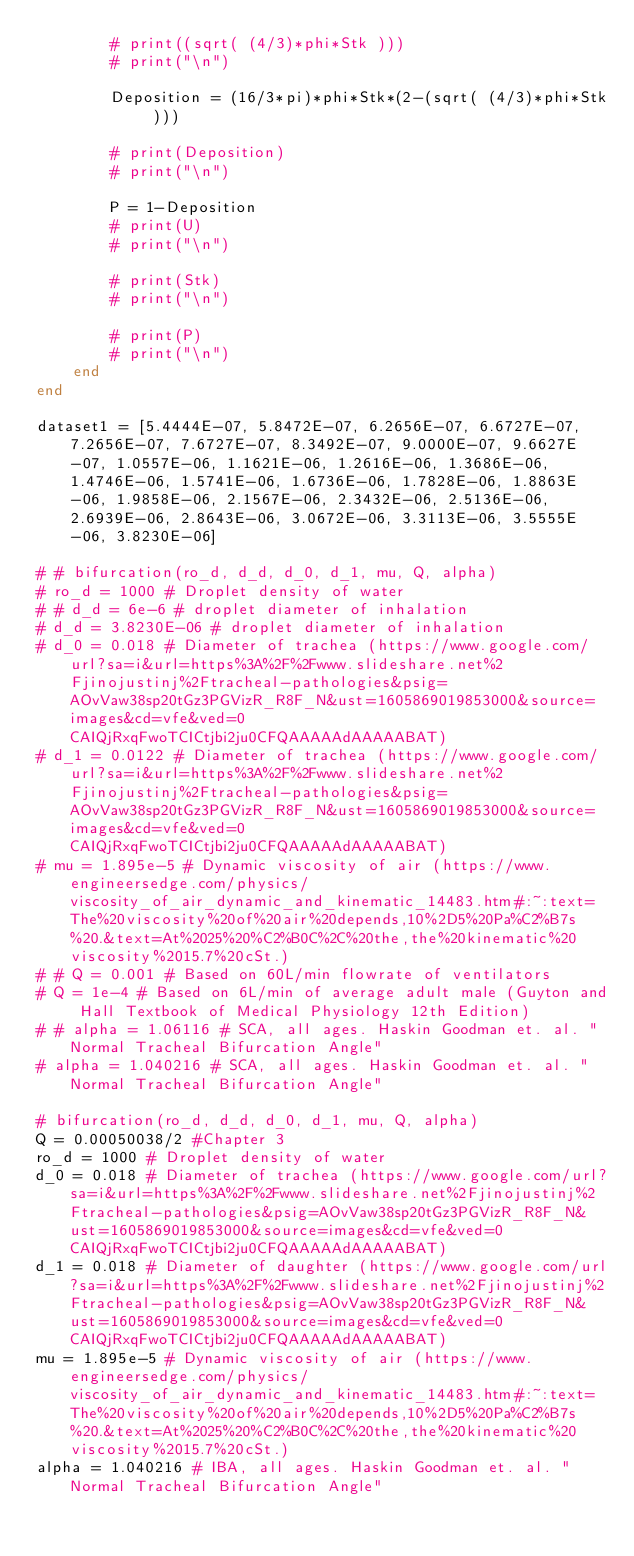<code> <loc_0><loc_0><loc_500><loc_500><_Julia_>        # print((sqrt( (4/3)*phi*Stk )))
        # print("\n")

        Deposition = (16/3*pi)*phi*Stk*(2-(sqrt( (4/3)*phi*Stk )))

        # print(Deposition)
        # print("\n")

        P = 1-Deposition
        # print(U)
        # print("\n")

        # print(Stk)
        # print("\n")

        # print(P)
        # print("\n")
    end
end

dataset1 = [5.4444E-07, 5.8472E-07, 6.2656E-07, 6.6727E-07, 7.2656E-07, 7.6727E-07, 8.3492E-07, 9.0000E-07, 9.6627E-07, 1.0557E-06, 1.1621E-06, 1.2616E-06, 1.3686E-06, 1.4746E-06, 1.5741E-06, 1.6736E-06, 1.7828E-06, 1.8863E-06, 1.9858E-06, 2.1567E-06, 2.3432E-06, 2.5136E-06, 2.6939E-06, 2.8643E-06, 3.0672E-06, 3.3113E-06, 3.5555E-06, 3.8230E-06]

# # bifurcation(ro_d, d_d, d_0, d_1, mu, Q, alpha)
# ro_d = 1000 # Droplet density of water
# # d_d = 6e-6 # droplet diameter of inhalation
# d_d = 3.8230E-06 # droplet diameter of inhalation
# d_0 = 0.018 # Diameter of trachea (https://www.google.com/url?sa=i&url=https%3A%2F%2Fwww.slideshare.net%2Fjinojustinj%2Ftracheal-pathologies&psig=AOvVaw38sp20tGz3PGVizR_R8F_N&ust=1605869019853000&source=images&cd=vfe&ved=0CAIQjRxqFwoTCICtjbi2ju0CFQAAAAAdAAAAABAT)
# d_1 = 0.0122 # Diameter of trachea (https://www.google.com/url?sa=i&url=https%3A%2F%2Fwww.slideshare.net%2Fjinojustinj%2Ftracheal-pathologies&psig=AOvVaw38sp20tGz3PGVizR_R8F_N&ust=1605869019853000&source=images&cd=vfe&ved=0CAIQjRxqFwoTCICtjbi2ju0CFQAAAAAdAAAAABAT)
# mu = 1.895e-5 # Dynamic viscosity of air (https://www.engineersedge.com/physics/viscosity_of_air_dynamic_and_kinematic_14483.htm#:~:text=The%20viscosity%20of%20air%20depends,10%2D5%20Pa%C2%B7s%20.&text=At%2025%20%C2%B0C%2C%20the,the%20kinematic%20viscosity%2015.7%20cSt.)
# # Q = 0.001 # Based on 60L/min flowrate of ventilators
# Q = 1e-4 # Based on 6L/min of average adult male (Guyton and Hall Textbook of Medical Physiology 12th Edition)
# # alpha = 1.06116 # SCA, all ages. Haskin Goodman et. al. "Normal Tracheal Bifurcation Angle"
# alpha = 1.040216 # SCA, all ages. Haskin Goodman et. al. "Normal Tracheal Bifurcation Angle"

# bifurcation(ro_d, d_d, d_0, d_1, mu, Q, alpha)
Q = 0.00050038/2 #Chapter 3
ro_d = 1000 # Droplet density of water
d_0 = 0.018 # Diameter of trachea (https://www.google.com/url?sa=i&url=https%3A%2F%2Fwww.slideshare.net%2Fjinojustinj%2Ftracheal-pathologies&psig=AOvVaw38sp20tGz3PGVizR_R8F_N&ust=1605869019853000&source=images&cd=vfe&ved=0CAIQjRxqFwoTCICtjbi2ju0CFQAAAAAdAAAAABAT)
d_1 = 0.018 # Diameter of daughter (https://www.google.com/url?sa=i&url=https%3A%2F%2Fwww.slideshare.net%2Fjinojustinj%2Ftracheal-pathologies&psig=AOvVaw38sp20tGz3PGVizR_R8F_N&ust=1605869019853000&source=images&cd=vfe&ved=0CAIQjRxqFwoTCICtjbi2ju0CFQAAAAAdAAAAABAT)
mu = 1.895e-5 # Dynamic viscosity of air (https://www.engineersedge.com/physics/viscosity_of_air_dynamic_and_kinematic_14483.htm#:~:text=The%20viscosity%20of%20air%20depends,10%2D5%20Pa%C2%B7s%20.&text=At%2025%20%C2%B0C%2C%20the,the%20kinematic%20viscosity%2015.7%20cSt.)
alpha = 1.040216 # IBA, all ages. Haskin Goodman et. al. "Normal Tracheal Bifurcation Angle"</code> 